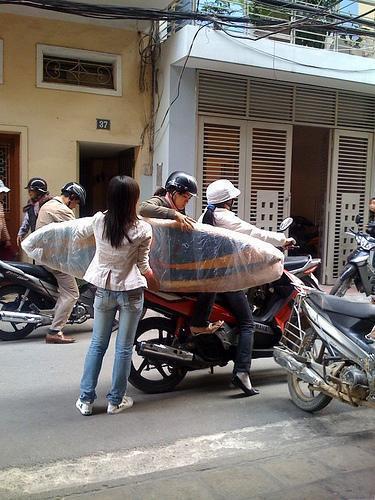What is the cellophane wrapping applied over top of?
Make your selection and explain in format: 'Answer: answer
Rationale: rationale.'
Options: Helmet, surfboard, bike, package. Answer: surfboard.
Rationale: You can tell by it's long shape and flat body.  this is characteristic of this type of sports equipment and it is carried in the matter shown. What color is the background on the surfboard wrapped up with cello wrap?
Select the accurate response from the four choices given to answer the question.
Options: White, green, blue, yellow. Blue. 